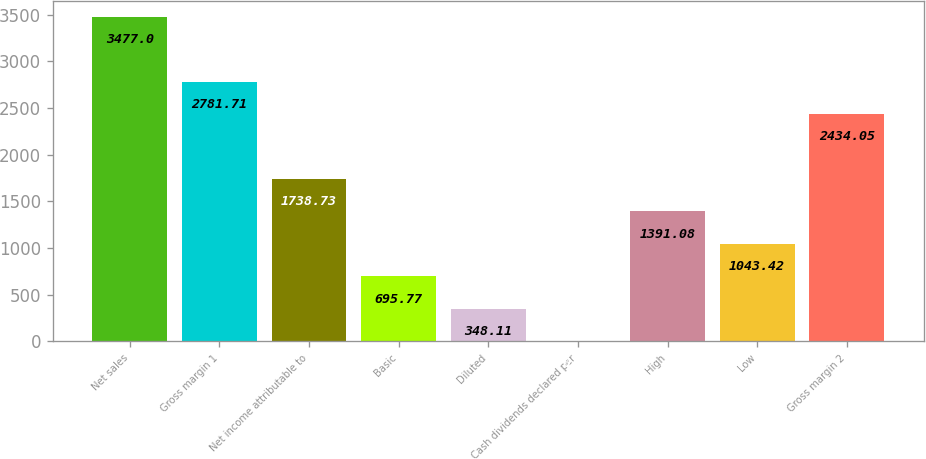<chart> <loc_0><loc_0><loc_500><loc_500><bar_chart><fcel>Net sales<fcel>Gross margin 1<fcel>Net income attributable to<fcel>Basic<fcel>Diluted<fcel>Cash dividends declared per<fcel>High<fcel>Low<fcel>Gross margin 2<nl><fcel>3477<fcel>2781.71<fcel>1738.73<fcel>695.77<fcel>348.11<fcel>0.45<fcel>1391.08<fcel>1043.42<fcel>2434.05<nl></chart> 